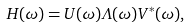Convert formula to latex. <formula><loc_0><loc_0><loc_500><loc_500>H ( \omega ) = U ( \omega ) \Lambda ( \omega ) V ^ { * } ( \omega ) ,</formula> 